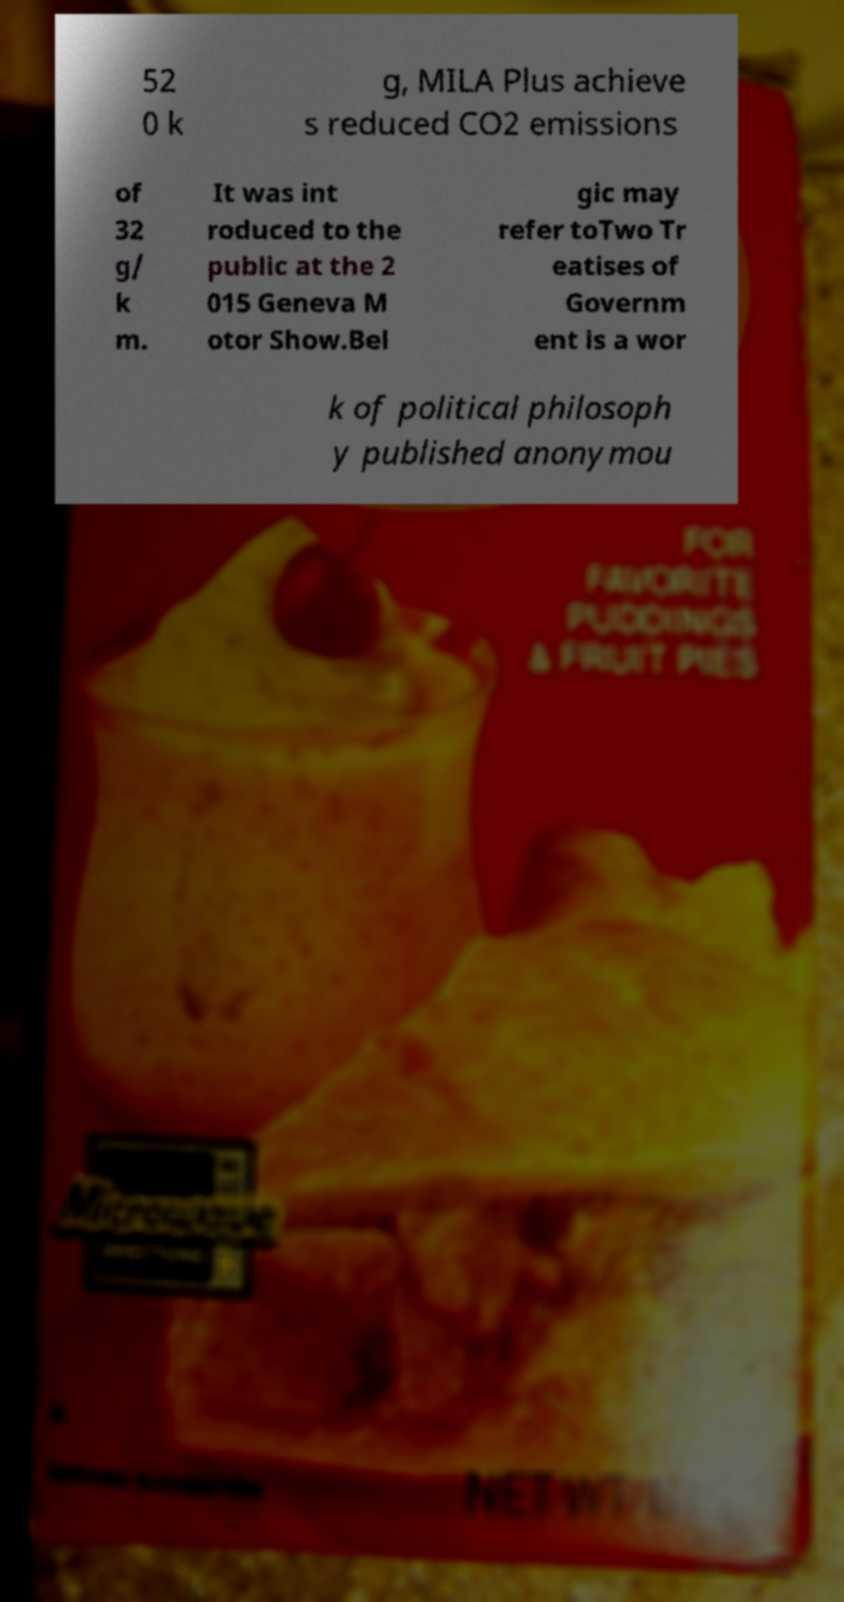For documentation purposes, I need the text within this image transcribed. Could you provide that? 52 0 k g, MILA Plus achieve s reduced CO2 emissions of 32 g/ k m. It was int roduced to the public at the 2 015 Geneva M otor Show.Bel gic may refer toTwo Tr eatises of Governm ent is a wor k of political philosoph y published anonymou 